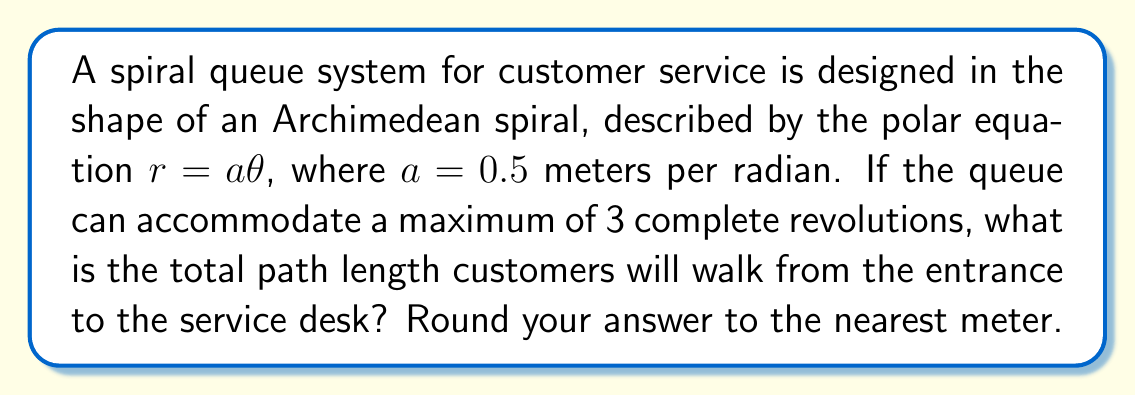Provide a solution to this math problem. To solve this problem, we need to follow these steps:

1) The Archimedean spiral is given by $r = a\theta$, where $a = 0.5$ m/rad.

2) For 3 complete revolutions, $\theta$ ranges from 0 to $6\pi$ radians.

3) The arc length of a polar curve is given by the formula:

   $$L = \int_0^{\theta} \sqrt{r^2 + \left(\frac{dr}{d\theta}\right)^2} d\theta$$

4) For our spiral, $r = 0.5\theta$ and $\frac{dr}{d\theta} = 0.5$

5) Substituting these into the arc length formula:

   $$L = \int_0^{6\pi} \sqrt{(0.5\theta)^2 + (0.5)^2} d\theta$$

6) Simplify:

   $$L = \int_0^{6\pi} \sqrt{0.25\theta^2 + 0.25} d\theta = 0.5\int_0^{6\pi} \sqrt{\theta^2 + 1} d\theta$$

7) This integral doesn't have an elementary antiderivative. We can solve it using the substitution $\theta = \sinh u$:

   $$L = 0.5\int_0^{\sinh^{-1}(6\pi)} \sqrt{\sinh^2 u + 1} \cosh u du = 0.5\int_0^{\sinh^{-1}(6\pi)} \cosh^2 u du$$

8) The antiderivative of $\cosh^2 u$ is $\frac{1}{2}u + \frac{1}{4}\sinh(2u)$, so:

   $$L = 0.25[\sinh^{-1}(6\pi) + \frac{1}{2}\sinh(2\sinh^{-1}(6\pi))]$$

9) Evaluating this (you would use a calculator for this step):

   $$L \approx 28.56 \text{ meters}$$

10) Rounding to the nearest meter:

    $$L \approx 29 \text{ meters}$$
Answer: 29 meters 